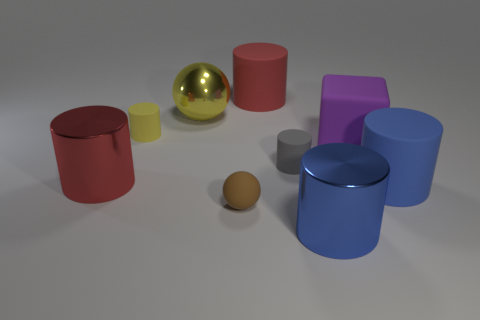How many metal objects have the same color as the small rubber sphere?
Offer a terse response. 0. There is a big metal thing right of the large red matte object; does it have the same shape as the brown matte object that is in front of the purple cube?
Offer a terse response. No. How many cylinders are to the right of the big blue cylinder left of the large blue thing on the right side of the blue metal cylinder?
Provide a succinct answer. 1. The small object in front of the large cylinder to the right of the large metallic cylinder right of the gray rubber cylinder is made of what material?
Keep it short and to the point. Rubber. Is the material of the blue thing that is to the right of the large block the same as the tiny gray object?
Ensure brevity in your answer.  Yes. How many yellow metal spheres are the same size as the cube?
Your answer should be compact. 1. Is the number of spheres in front of the big blue matte object greater than the number of metal objects behind the large red rubber thing?
Your answer should be very brief. Yes. Are there any small matte things of the same shape as the large yellow shiny object?
Ensure brevity in your answer.  Yes. There is a rubber cylinder that is in front of the big red object in front of the gray rubber cylinder; how big is it?
Make the answer very short. Large. What is the shape of the small thing that is in front of the large cylinder that is to the left of the large red thing behind the matte block?
Ensure brevity in your answer.  Sphere. 